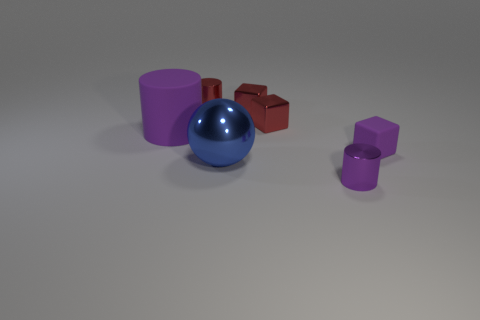Subtract all purple cylinders. How many red cubes are left? 2 Subtract all tiny purple matte blocks. How many blocks are left? 2 Add 3 small metallic blocks. How many objects exist? 10 Subtract all cubes. How many objects are left? 4 Subtract 0 cyan cubes. How many objects are left? 7 Subtract all green cylinders. Subtract all yellow balls. How many cylinders are left? 3 Subtract all small purple cubes. Subtract all blue metallic spheres. How many objects are left? 5 Add 1 big blue shiny objects. How many big blue shiny objects are left? 2 Add 2 big purple cylinders. How many big purple cylinders exist? 3 